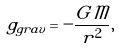Convert formula to latex. <formula><loc_0><loc_0><loc_500><loc_500>g _ { g r a v } = - \frac { G \mathcal { M } } { r ^ { 2 } } ,</formula> 